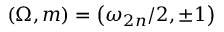<formula> <loc_0><loc_0><loc_500><loc_500>\left ( \Omega , m \right ) = \left ( \omega _ { 2 n } / 2 , \pm 1 \right )</formula> 